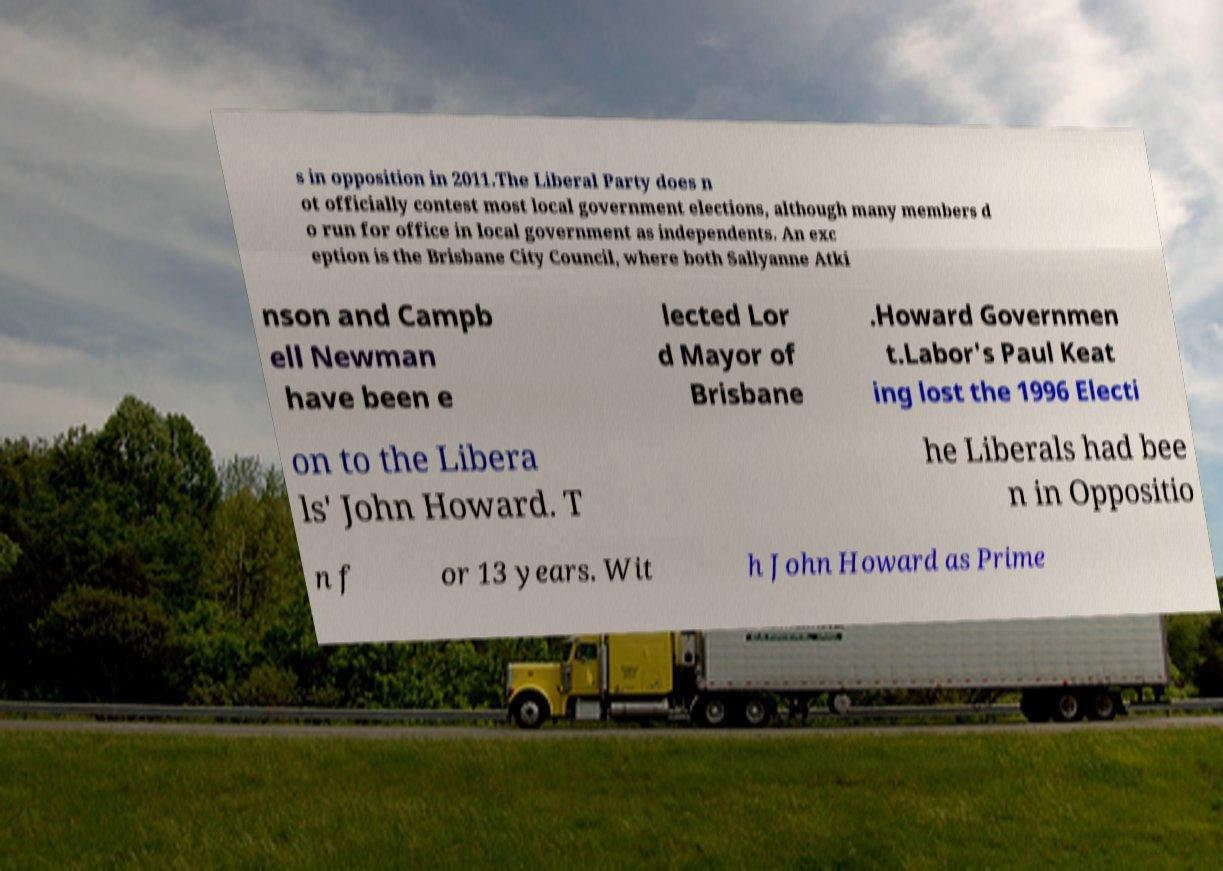There's text embedded in this image that I need extracted. Can you transcribe it verbatim? s in opposition in 2011.The Liberal Party does n ot officially contest most local government elections, although many members d o run for office in local government as independents. An exc eption is the Brisbane City Council, where both Sallyanne Atki nson and Campb ell Newman have been e lected Lor d Mayor of Brisbane .Howard Governmen t.Labor's Paul Keat ing lost the 1996 Electi on to the Libera ls' John Howard. T he Liberals had bee n in Oppositio n f or 13 years. Wit h John Howard as Prime 